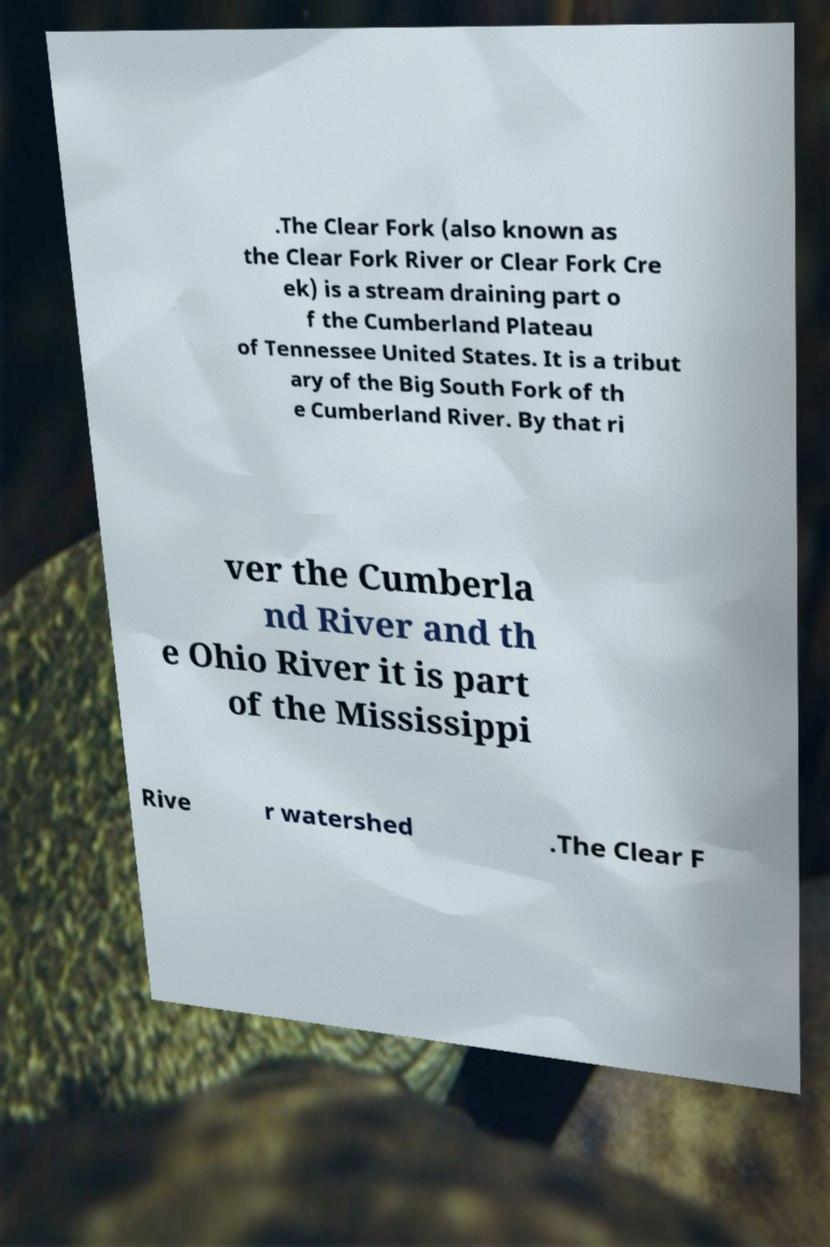For documentation purposes, I need the text within this image transcribed. Could you provide that? .The Clear Fork (also known as the Clear Fork River or Clear Fork Cre ek) is a stream draining part o f the Cumberland Plateau of Tennessee United States. It is a tribut ary of the Big South Fork of th e Cumberland River. By that ri ver the Cumberla nd River and th e Ohio River it is part of the Mississippi Rive r watershed .The Clear F 